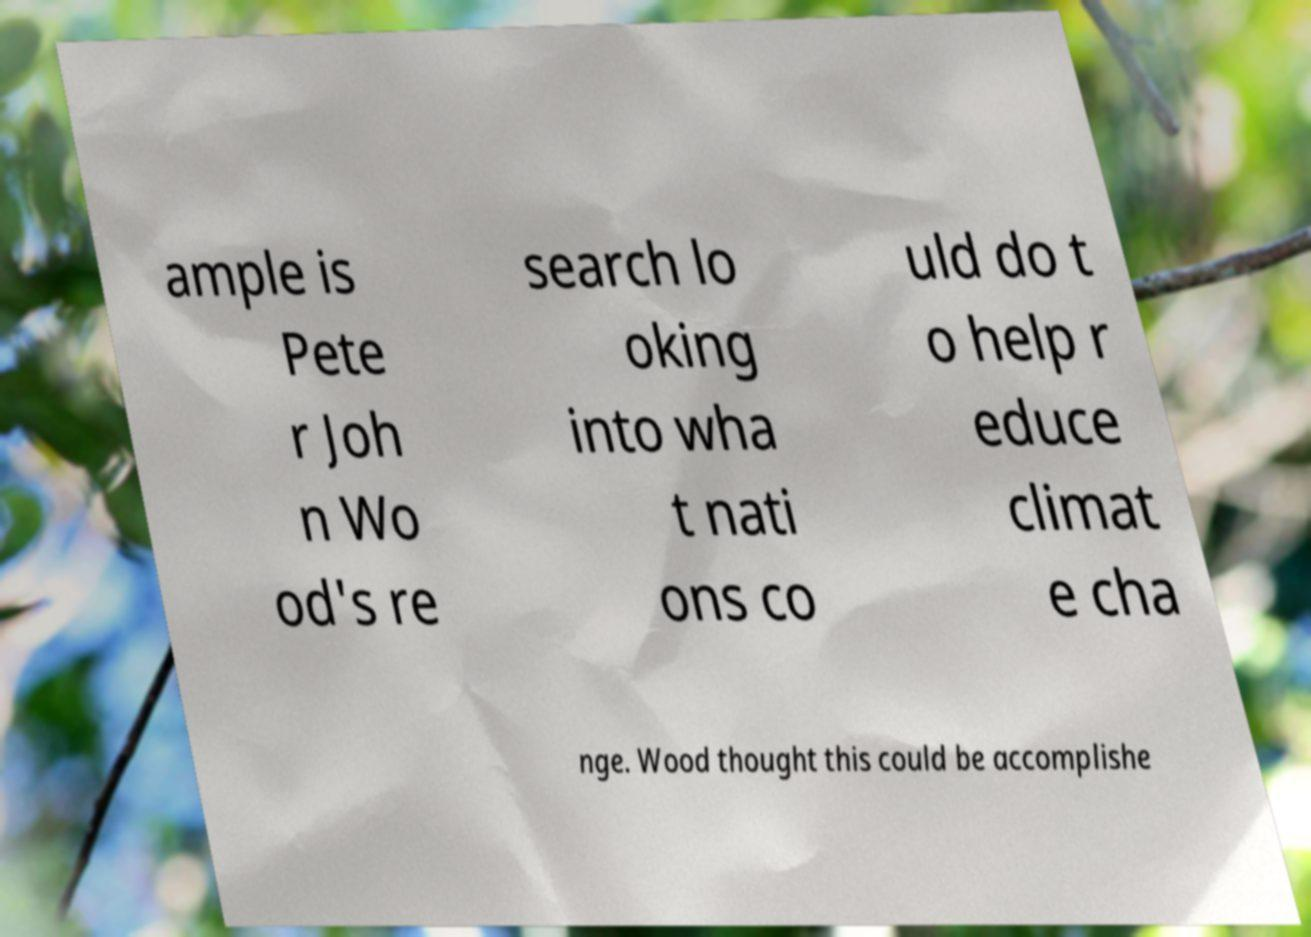Please identify and transcribe the text found in this image. ample is Pete r Joh n Wo od's re search lo oking into wha t nati ons co uld do t o help r educe climat e cha nge. Wood thought this could be accomplishe 